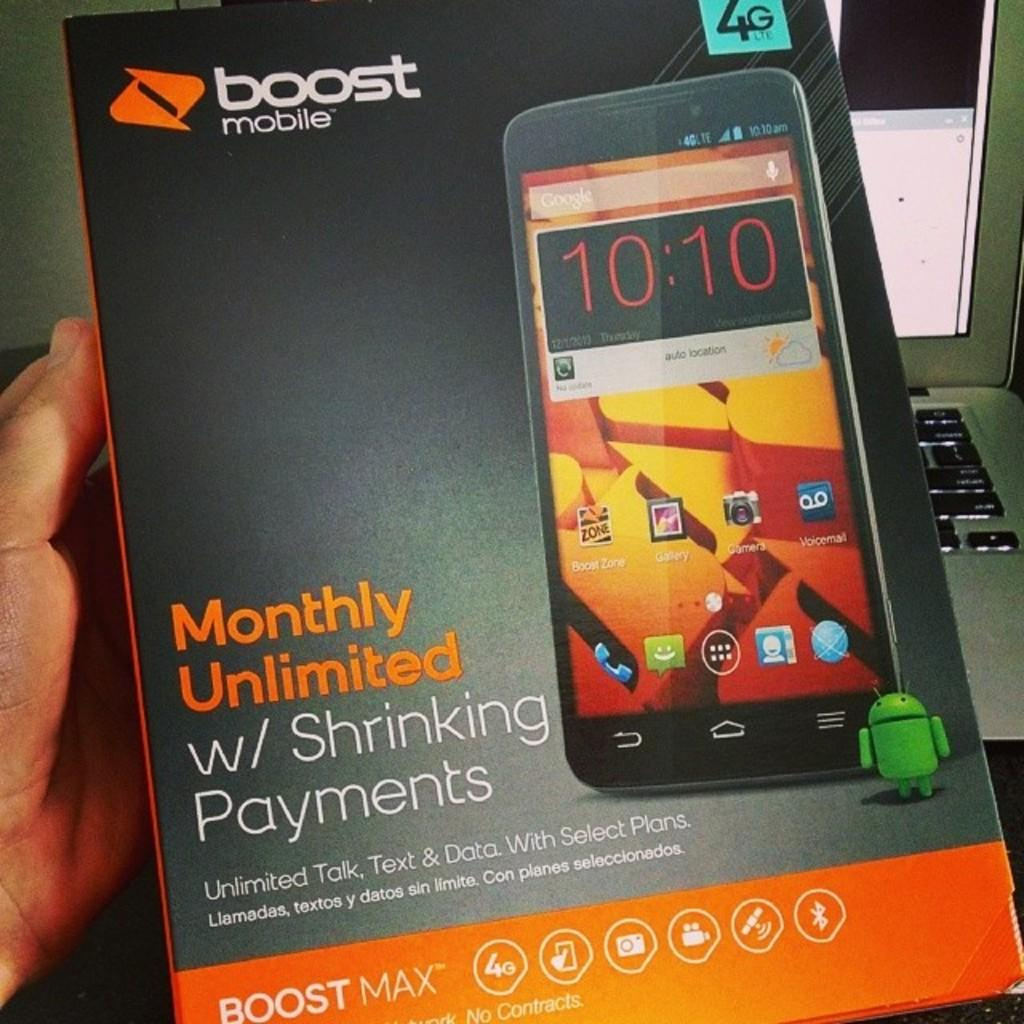What object is the main focus of the image? There is a mobile box in the image. Can you describe any other objects or body parts visible in the image? There is a person's hand on the left side of the image, and a laptop is on the right side of the image. What type of notebook is being used by the person in the image? There is no notebook present in the image. Is the person in the image offering something to someone else? The image does not provide any information about the person offering something to someone else. 